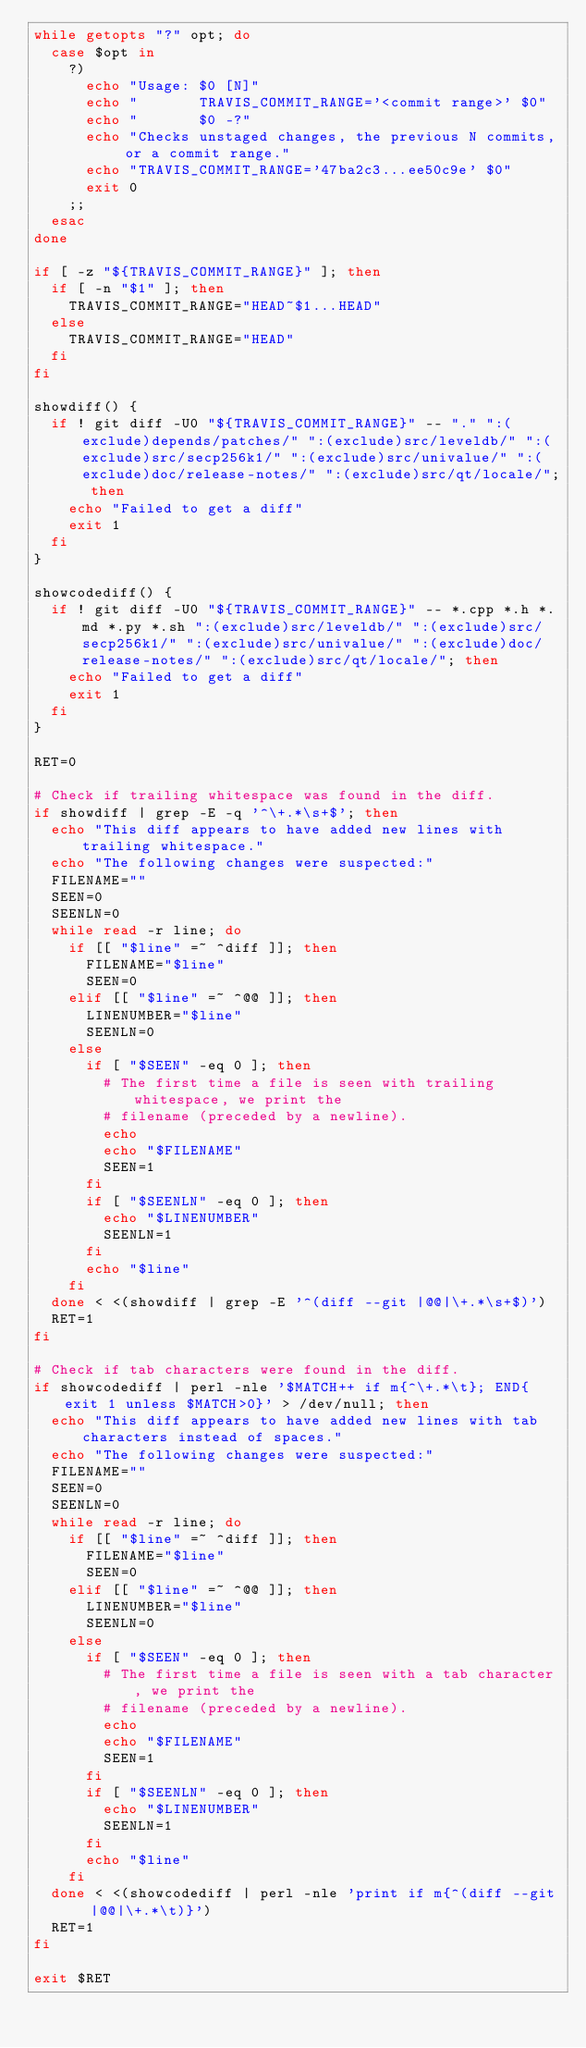<code> <loc_0><loc_0><loc_500><loc_500><_Bash_>while getopts "?" opt; do
  case $opt in
    ?)
      echo "Usage: $0 [N]"
      echo "       TRAVIS_COMMIT_RANGE='<commit range>' $0"
      echo "       $0 -?"
      echo "Checks unstaged changes, the previous N commits, or a commit range."
      echo "TRAVIS_COMMIT_RANGE='47ba2c3...ee50c9e' $0"
      exit 0
    ;;
  esac
done

if [ -z "${TRAVIS_COMMIT_RANGE}" ]; then
  if [ -n "$1" ]; then
    TRAVIS_COMMIT_RANGE="HEAD~$1...HEAD"
  else
    TRAVIS_COMMIT_RANGE="HEAD"
  fi
fi

showdiff() {
  if ! git diff -U0 "${TRAVIS_COMMIT_RANGE}" -- "." ":(exclude)depends/patches/" ":(exclude)src/leveldb/" ":(exclude)src/secp256k1/" ":(exclude)src/univalue/" ":(exclude)doc/release-notes/" ":(exclude)src/qt/locale/"; then
    echo "Failed to get a diff"
    exit 1
  fi
}

showcodediff() {
  if ! git diff -U0 "${TRAVIS_COMMIT_RANGE}" -- *.cpp *.h *.md *.py *.sh ":(exclude)src/leveldb/" ":(exclude)src/secp256k1/" ":(exclude)src/univalue/" ":(exclude)doc/release-notes/" ":(exclude)src/qt/locale/"; then
    echo "Failed to get a diff"
    exit 1
  fi
}

RET=0

# Check if trailing whitespace was found in the diff.
if showdiff | grep -E -q '^\+.*\s+$'; then
  echo "This diff appears to have added new lines with trailing whitespace."
  echo "The following changes were suspected:"
  FILENAME=""
  SEEN=0
  SEENLN=0
  while read -r line; do
    if [[ "$line" =~ ^diff ]]; then
      FILENAME="$line"
      SEEN=0
    elif [[ "$line" =~ ^@@ ]]; then
      LINENUMBER="$line"
      SEENLN=0
    else
      if [ "$SEEN" -eq 0 ]; then
        # The first time a file is seen with trailing whitespace, we print the
        # filename (preceded by a newline).
        echo
        echo "$FILENAME"
        SEEN=1
      fi
      if [ "$SEENLN" -eq 0 ]; then
        echo "$LINENUMBER"
        SEENLN=1
      fi
      echo "$line"
    fi
  done < <(showdiff | grep -E '^(diff --git |@@|\+.*\s+$)')
  RET=1
fi

# Check if tab characters were found in the diff.
if showcodediff | perl -nle '$MATCH++ if m{^\+.*\t}; END{exit 1 unless $MATCH>0}' > /dev/null; then
  echo "This diff appears to have added new lines with tab characters instead of spaces."
  echo "The following changes were suspected:"
  FILENAME=""
  SEEN=0
  SEENLN=0
  while read -r line; do
    if [[ "$line" =~ ^diff ]]; then
      FILENAME="$line"
      SEEN=0
    elif [[ "$line" =~ ^@@ ]]; then
      LINENUMBER="$line"
      SEENLN=0
    else
      if [ "$SEEN" -eq 0 ]; then
        # The first time a file is seen with a tab character, we print the
        # filename (preceded by a newline).
        echo
        echo "$FILENAME"
        SEEN=1
      fi
      if [ "$SEENLN" -eq 0 ]; then
        echo "$LINENUMBER"
        SEENLN=1
      fi
      echo "$line"
    fi
  done < <(showcodediff | perl -nle 'print if m{^(diff --git |@@|\+.*\t)}')
  RET=1
fi

exit $RET
</code> 